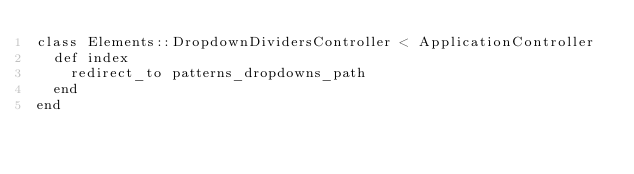Convert code to text. <code><loc_0><loc_0><loc_500><loc_500><_Ruby_>class Elements::DropdownDividersController < ApplicationController
  def index
    redirect_to patterns_dropdowns_path
  end
end
</code> 